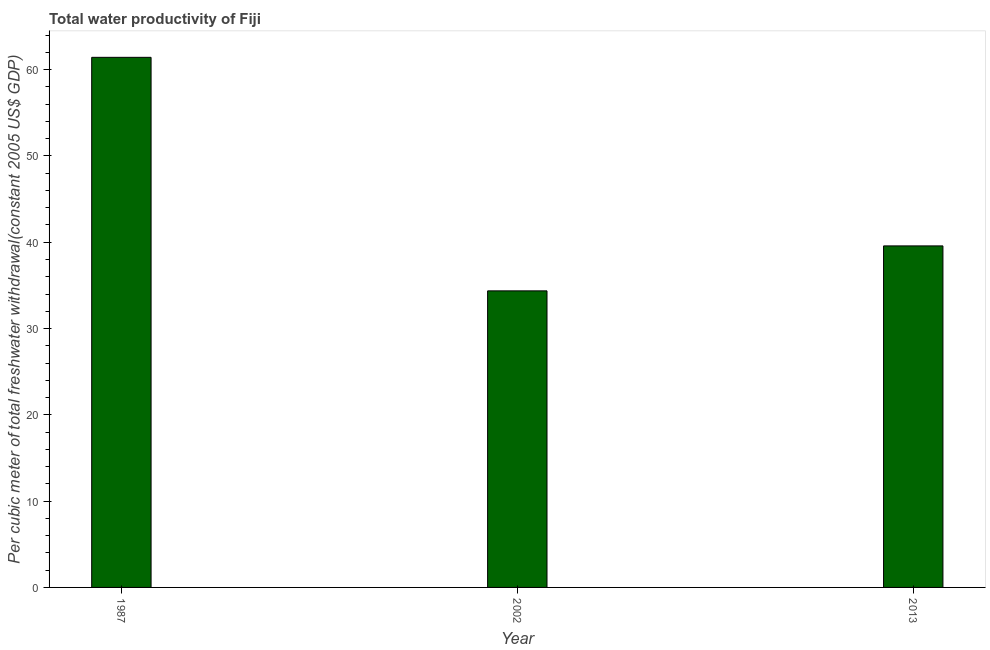What is the title of the graph?
Make the answer very short. Total water productivity of Fiji. What is the label or title of the X-axis?
Offer a terse response. Year. What is the label or title of the Y-axis?
Make the answer very short. Per cubic meter of total freshwater withdrawal(constant 2005 US$ GDP). What is the total water productivity in 2002?
Your answer should be very brief. 34.36. Across all years, what is the maximum total water productivity?
Give a very brief answer. 61.42. Across all years, what is the minimum total water productivity?
Offer a very short reply. 34.36. In which year was the total water productivity minimum?
Ensure brevity in your answer.  2002. What is the sum of the total water productivity?
Your answer should be very brief. 135.36. What is the difference between the total water productivity in 1987 and 2013?
Your answer should be very brief. 21.85. What is the average total water productivity per year?
Ensure brevity in your answer.  45.12. What is the median total water productivity?
Provide a short and direct response. 39.57. What is the ratio of the total water productivity in 1987 to that in 2002?
Provide a succinct answer. 1.79. Is the total water productivity in 1987 less than that in 2013?
Your answer should be compact. No. What is the difference between the highest and the second highest total water productivity?
Make the answer very short. 21.85. Is the sum of the total water productivity in 1987 and 2002 greater than the maximum total water productivity across all years?
Make the answer very short. Yes. What is the difference between the highest and the lowest total water productivity?
Make the answer very short. 27.06. How many bars are there?
Your answer should be very brief. 3. Are the values on the major ticks of Y-axis written in scientific E-notation?
Provide a short and direct response. No. What is the Per cubic meter of total freshwater withdrawal(constant 2005 US$ GDP) of 1987?
Your response must be concise. 61.42. What is the Per cubic meter of total freshwater withdrawal(constant 2005 US$ GDP) of 2002?
Offer a very short reply. 34.36. What is the Per cubic meter of total freshwater withdrawal(constant 2005 US$ GDP) of 2013?
Offer a very short reply. 39.57. What is the difference between the Per cubic meter of total freshwater withdrawal(constant 2005 US$ GDP) in 1987 and 2002?
Ensure brevity in your answer.  27.06. What is the difference between the Per cubic meter of total freshwater withdrawal(constant 2005 US$ GDP) in 1987 and 2013?
Your answer should be very brief. 21.85. What is the difference between the Per cubic meter of total freshwater withdrawal(constant 2005 US$ GDP) in 2002 and 2013?
Your answer should be very brief. -5.21. What is the ratio of the Per cubic meter of total freshwater withdrawal(constant 2005 US$ GDP) in 1987 to that in 2002?
Your answer should be very brief. 1.79. What is the ratio of the Per cubic meter of total freshwater withdrawal(constant 2005 US$ GDP) in 1987 to that in 2013?
Your answer should be very brief. 1.55. What is the ratio of the Per cubic meter of total freshwater withdrawal(constant 2005 US$ GDP) in 2002 to that in 2013?
Give a very brief answer. 0.87. 